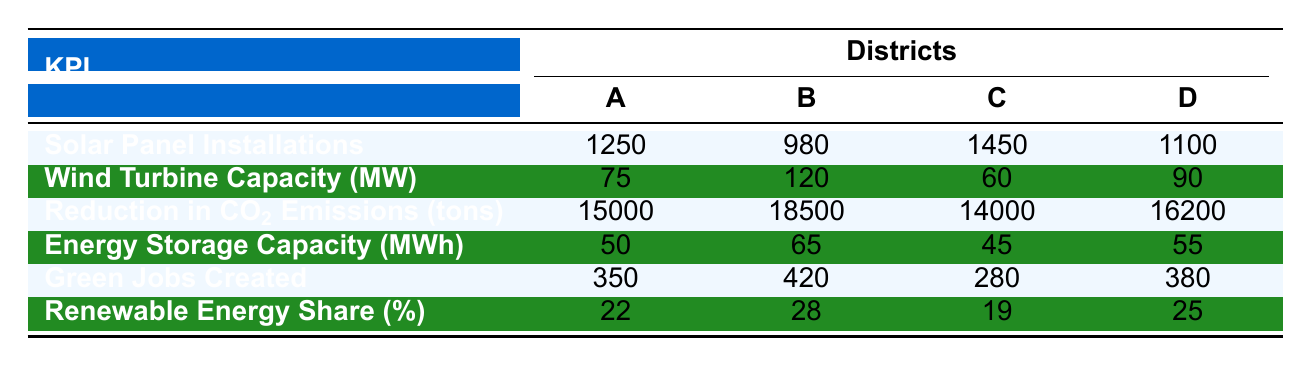What is the total number of Solar Panel Installations across all districts? To find the total, sum the Solar Panel Installations for all districts: 1250 (District A) + 980 (District B) + 1450 (District C) + 1100 (District D) = 3780
Answer: 3780 Which district has the highest Wind Turbine Capacity? Looking at the Wind Turbine Capacity values, District B has the highest value at 120 MW, while the other districts have lower capacities of 75, 60, and 90 MW respectively.
Answer: District B Is the Renewable Energy Share of District C more than 20%? The Renewable Energy Share for District C is 19%. Since 19% is less than 20%, the answer is no.
Answer: No What is the average Reduction in CO2 Emissions across all districts? To find the average, first sum the CO2 Emissions: 15000 + 18500 + 14000 + 16200 = 63700. Then divide by the number of districts, which is 4: 63700 / 4 = 15925.
Answer: 15925 Which district created the least number of Green Jobs? Looking at the Green Jobs Created row, District C has the lowest number at 280, while the other districts have higher values of 350, 420, and 380.
Answer: District C How much higher is the Wind Turbine Capacity of District B compared to District D? The Wind Turbine Capacity for District B is 120 MW and for District D it is 90 MW. The difference is 120 - 90 = 30 MW.
Answer: 30 MW Is the Energy Storage Capacity for District A greater than that of District C? The Energy Storage Capacity for District A is 50 MWh, and for District C, it is 45 MWh. 50 MWh is greater than 45 MWh, so the answer is yes.
Answer: Yes What is the combined Green Jobs Created for Districts A and D? Adding the Green Jobs Created for District A (350) and District D (380) gives a total of 350 + 380 = 730.
Answer: 730 Which district has the lowest Solar Panel Installations? From the Solar Panel Installations row, District B has the lowest number at 980, compared to 1250, 1450, and 1100 for the other districts.
Answer: District B 